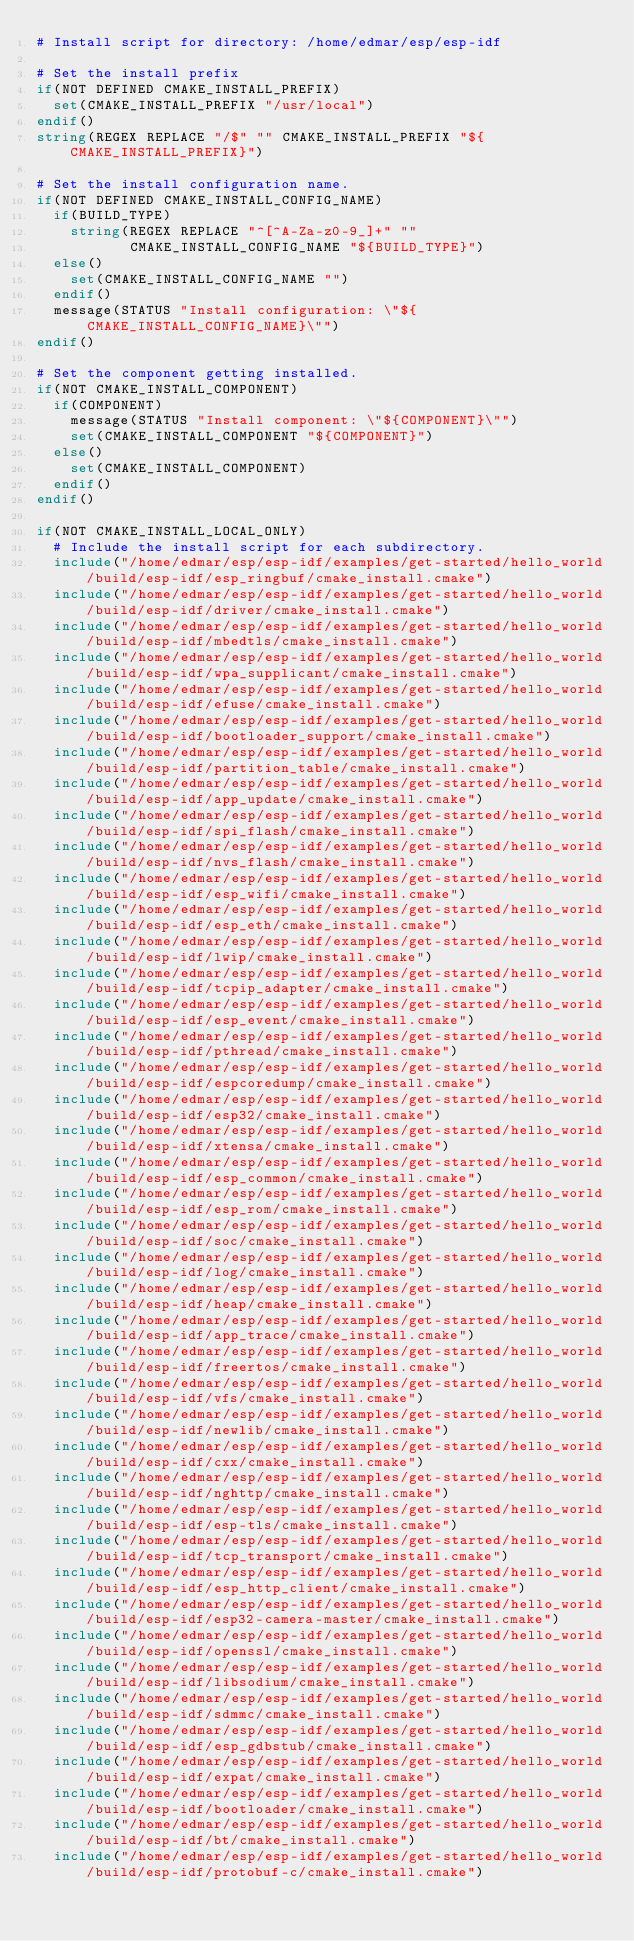<code> <loc_0><loc_0><loc_500><loc_500><_CMake_># Install script for directory: /home/edmar/esp/esp-idf

# Set the install prefix
if(NOT DEFINED CMAKE_INSTALL_PREFIX)
  set(CMAKE_INSTALL_PREFIX "/usr/local")
endif()
string(REGEX REPLACE "/$" "" CMAKE_INSTALL_PREFIX "${CMAKE_INSTALL_PREFIX}")

# Set the install configuration name.
if(NOT DEFINED CMAKE_INSTALL_CONFIG_NAME)
  if(BUILD_TYPE)
    string(REGEX REPLACE "^[^A-Za-z0-9_]+" ""
           CMAKE_INSTALL_CONFIG_NAME "${BUILD_TYPE}")
  else()
    set(CMAKE_INSTALL_CONFIG_NAME "")
  endif()
  message(STATUS "Install configuration: \"${CMAKE_INSTALL_CONFIG_NAME}\"")
endif()

# Set the component getting installed.
if(NOT CMAKE_INSTALL_COMPONENT)
  if(COMPONENT)
    message(STATUS "Install component: \"${COMPONENT}\"")
    set(CMAKE_INSTALL_COMPONENT "${COMPONENT}")
  else()
    set(CMAKE_INSTALL_COMPONENT)
  endif()
endif()

if(NOT CMAKE_INSTALL_LOCAL_ONLY)
  # Include the install script for each subdirectory.
  include("/home/edmar/esp/esp-idf/examples/get-started/hello_world/build/esp-idf/esp_ringbuf/cmake_install.cmake")
  include("/home/edmar/esp/esp-idf/examples/get-started/hello_world/build/esp-idf/driver/cmake_install.cmake")
  include("/home/edmar/esp/esp-idf/examples/get-started/hello_world/build/esp-idf/mbedtls/cmake_install.cmake")
  include("/home/edmar/esp/esp-idf/examples/get-started/hello_world/build/esp-idf/wpa_supplicant/cmake_install.cmake")
  include("/home/edmar/esp/esp-idf/examples/get-started/hello_world/build/esp-idf/efuse/cmake_install.cmake")
  include("/home/edmar/esp/esp-idf/examples/get-started/hello_world/build/esp-idf/bootloader_support/cmake_install.cmake")
  include("/home/edmar/esp/esp-idf/examples/get-started/hello_world/build/esp-idf/partition_table/cmake_install.cmake")
  include("/home/edmar/esp/esp-idf/examples/get-started/hello_world/build/esp-idf/app_update/cmake_install.cmake")
  include("/home/edmar/esp/esp-idf/examples/get-started/hello_world/build/esp-idf/spi_flash/cmake_install.cmake")
  include("/home/edmar/esp/esp-idf/examples/get-started/hello_world/build/esp-idf/nvs_flash/cmake_install.cmake")
  include("/home/edmar/esp/esp-idf/examples/get-started/hello_world/build/esp-idf/esp_wifi/cmake_install.cmake")
  include("/home/edmar/esp/esp-idf/examples/get-started/hello_world/build/esp-idf/esp_eth/cmake_install.cmake")
  include("/home/edmar/esp/esp-idf/examples/get-started/hello_world/build/esp-idf/lwip/cmake_install.cmake")
  include("/home/edmar/esp/esp-idf/examples/get-started/hello_world/build/esp-idf/tcpip_adapter/cmake_install.cmake")
  include("/home/edmar/esp/esp-idf/examples/get-started/hello_world/build/esp-idf/esp_event/cmake_install.cmake")
  include("/home/edmar/esp/esp-idf/examples/get-started/hello_world/build/esp-idf/pthread/cmake_install.cmake")
  include("/home/edmar/esp/esp-idf/examples/get-started/hello_world/build/esp-idf/espcoredump/cmake_install.cmake")
  include("/home/edmar/esp/esp-idf/examples/get-started/hello_world/build/esp-idf/esp32/cmake_install.cmake")
  include("/home/edmar/esp/esp-idf/examples/get-started/hello_world/build/esp-idf/xtensa/cmake_install.cmake")
  include("/home/edmar/esp/esp-idf/examples/get-started/hello_world/build/esp-idf/esp_common/cmake_install.cmake")
  include("/home/edmar/esp/esp-idf/examples/get-started/hello_world/build/esp-idf/esp_rom/cmake_install.cmake")
  include("/home/edmar/esp/esp-idf/examples/get-started/hello_world/build/esp-idf/soc/cmake_install.cmake")
  include("/home/edmar/esp/esp-idf/examples/get-started/hello_world/build/esp-idf/log/cmake_install.cmake")
  include("/home/edmar/esp/esp-idf/examples/get-started/hello_world/build/esp-idf/heap/cmake_install.cmake")
  include("/home/edmar/esp/esp-idf/examples/get-started/hello_world/build/esp-idf/app_trace/cmake_install.cmake")
  include("/home/edmar/esp/esp-idf/examples/get-started/hello_world/build/esp-idf/freertos/cmake_install.cmake")
  include("/home/edmar/esp/esp-idf/examples/get-started/hello_world/build/esp-idf/vfs/cmake_install.cmake")
  include("/home/edmar/esp/esp-idf/examples/get-started/hello_world/build/esp-idf/newlib/cmake_install.cmake")
  include("/home/edmar/esp/esp-idf/examples/get-started/hello_world/build/esp-idf/cxx/cmake_install.cmake")
  include("/home/edmar/esp/esp-idf/examples/get-started/hello_world/build/esp-idf/nghttp/cmake_install.cmake")
  include("/home/edmar/esp/esp-idf/examples/get-started/hello_world/build/esp-idf/esp-tls/cmake_install.cmake")
  include("/home/edmar/esp/esp-idf/examples/get-started/hello_world/build/esp-idf/tcp_transport/cmake_install.cmake")
  include("/home/edmar/esp/esp-idf/examples/get-started/hello_world/build/esp-idf/esp_http_client/cmake_install.cmake")
  include("/home/edmar/esp/esp-idf/examples/get-started/hello_world/build/esp-idf/esp32-camera-master/cmake_install.cmake")
  include("/home/edmar/esp/esp-idf/examples/get-started/hello_world/build/esp-idf/openssl/cmake_install.cmake")
  include("/home/edmar/esp/esp-idf/examples/get-started/hello_world/build/esp-idf/libsodium/cmake_install.cmake")
  include("/home/edmar/esp/esp-idf/examples/get-started/hello_world/build/esp-idf/sdmmc/cmake_install.cmake")
  include("/home/edmar/esp/esp-idf/examples/get-started/hello_world/build/esp-idf/esp_gdbstub/cmake_install.cmake")
  include("/home/edmar/esp/esp-idf/examples/get-started/hello_world/build/esp-idf/expat/cmake_install.cmake")
  include("/home/edmar/esp/esp-idf/examples/get-started/hello_world/build/esp-idf/bootloader/cmake_install.cmake")
  include("/home/edmar/esp/esp-idf/examples/get-started/hello_world/build/esp-idf/bt/cmake_install.cmake")
  include("/home/edmar/esp/esp-idf/examples/get-started/hello_world/build/esp-idf/protobuf-c/cmake_install.cmake")</code> 